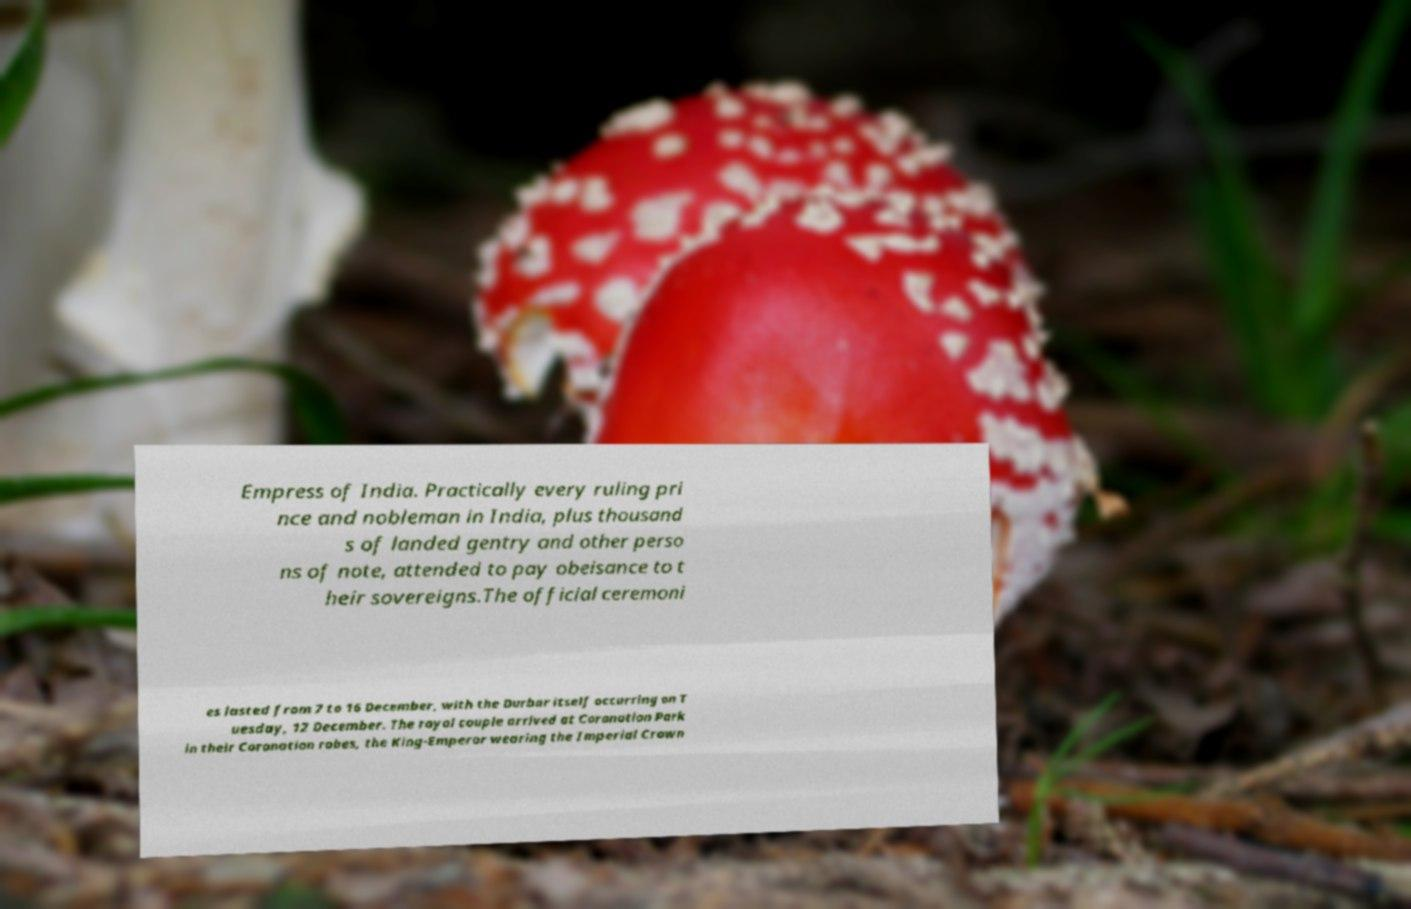For documentation purposes, I need the text within this image transcribed. Could you provide that? Empress of India. Practically every ruling pri nce and nobleman in India, plus thousand s of landed gentry and other perso ns of note, attended to pay obeisance to t heir sovereigns.The official ceremoni es lasted from 7 to 16 December, with the Durbar itself occurring on T uesday, 12 December. The royal couple arrived at Coronation Park in their Coronation robes, the King-Emperor wearing the Imperial Crown 